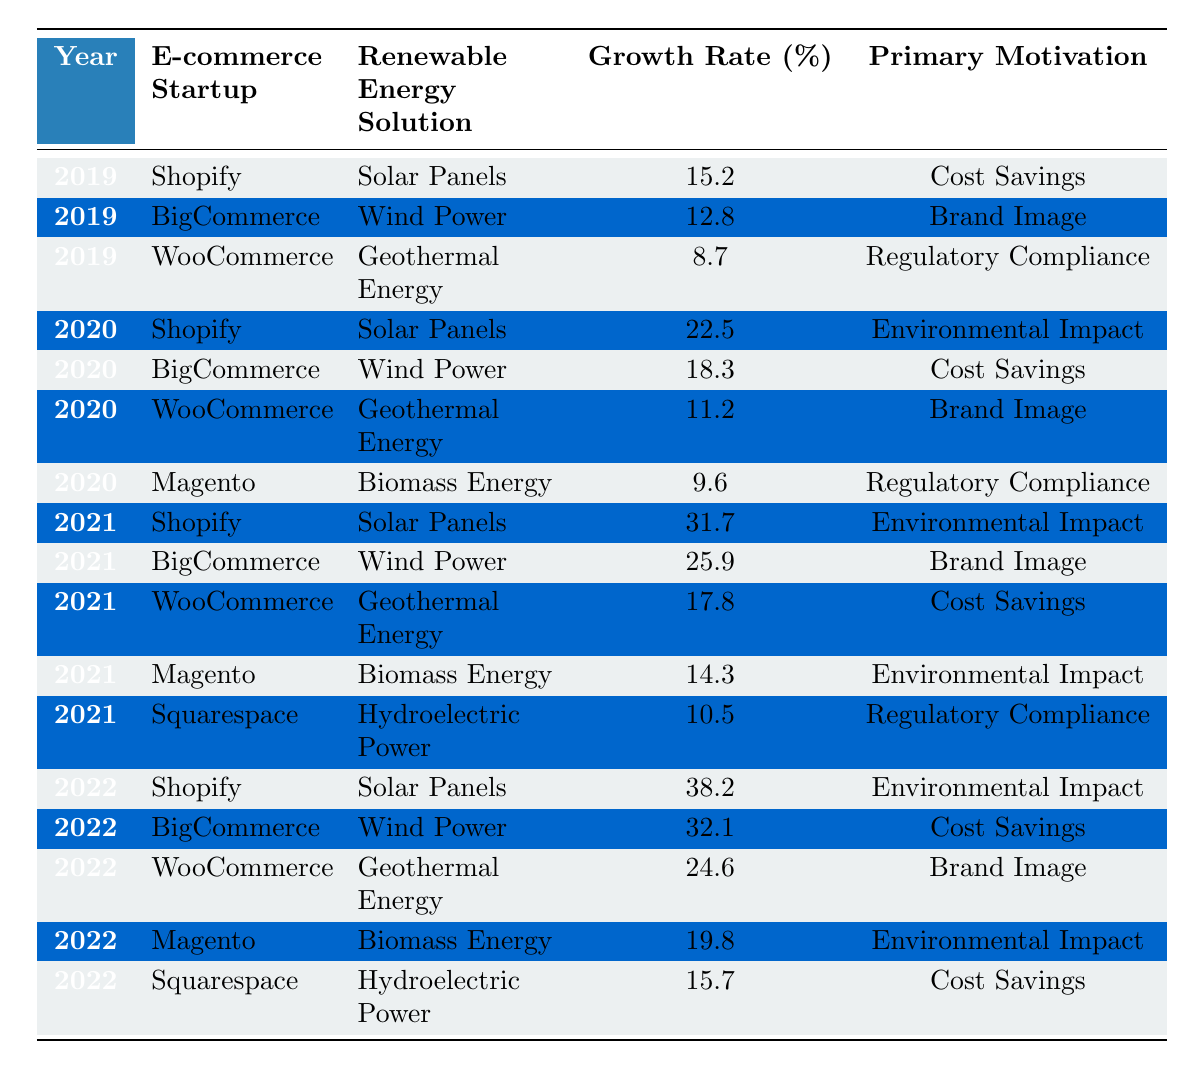What was the growth rate for Shopify's renewable energy solutions in 2021? In the table, the growth rate for Shopify in 2021 is explicitly listed as 31.7%.
Answer: 31.7% Which renewable energy solution had the highest growth rate in 2022? By comparing the growth rates in the 2022 data, Solar Panels for Shopify had the highest growth rate at 38.2%.
Answer: Solar Panels Did WooCommerce's growth rate increase or decrease from 2021 to 2022? In 2021, WooCommerce had a growth rate of 17.8%, and in 2022 it increased to 24.6%. Thus, the growth rate increased from 2021 to 2022.
Answer: Increased What was the average growth rate for BigCommerce from 2019 to 2022? The growth rates for BigCommerce are 12.8%, 18.3%, 25.9%, and 32.1%. Adding these gives 12.8 + 18.3 + 25.9 + 32.1 = 89.1. The average is 89.1 / 4 = 22.275.
Answer: 22.275 Which year saw the largest percentage increase in growth for any renewable energy solution? Transitioning from 2020 to 2021, Shopify's growth rate increased from 22.5% to 31.7%. The increase is 31.7 - 22.5 = 9.2%. No other solution saw a larger increase in this time frame.
Answer: 9.2% Is there a renewable energy solution that consistently had a growth rate above 10% from 2019 to 2022? Reviewing each year for every solution, Solar Panels for Shopify consistently showed growth rates at 15.2%, 22.5%, 31.7%, and 38.2%, all above 10%.
Answer: Yes Which company's renewable energy solution had the lowest growth rate in 2019? In 2019, WooCommerce had the lowest growth rate of 8.7% among the listed companies.
Answer: WooCommerce What is the total growth rate for all renewable energy solutions listed for 2020? The growth rates in 2020 are 22.5% (Shopify), 18.3% (BigCommerce), 11.2% (WooCommerce), and 9.6% (Magento). Summing these yields a total growth rate of 22.5 + 18.3 + 11.2 + 9.6 = 61.6%.
Answer: 61.6% Has Squarespace's primary motivation changed from 2019 to 2022 regarding renewable energy solutions? Squarespace's primary motivation in 2021 was Regulatory Compliance, while in 2022 it was Cost Savings, indicating a change.
Answer: Yes What was the difference in growth rate for biomass energy between 2020 and 2022? The growth rate for biomass energy in 2020 was 9.6% (Magento) and it increased to 19.8% in 2022. The difference is 19.8 - 9.6 = 10.2%.
Answer: 10.2% How many different renewable energy solutions showed a growth rate above 30% in 2022? Reviewing the 2022 data, Solar Panels and Wind Power both had growth rates exceeding 30% (38.2% and 32.1% respectively), making a total of 2 solutions.
Answer: 2 